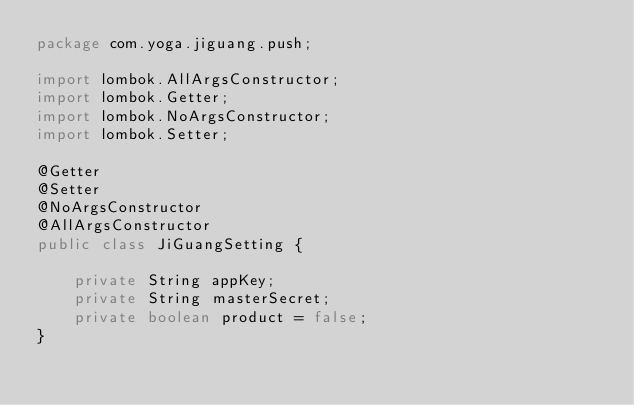Convert code to text. <code><loc_0><loc_0><loc_500><loc_500><_Java_>package com.yoga.jiguang.push;

import lombok.AllArgsConstructor;
import lombok.Getter;
import lombok.NoArgsConstructor;
import lombok.Setter;

@Getter
@Setter
@NoArgsConstructor
@AllArgsConstructor
public class JiGuangSetting {

    private String appKey;
    private String masterSecret;
    private boolean product = false;
}
</code> 